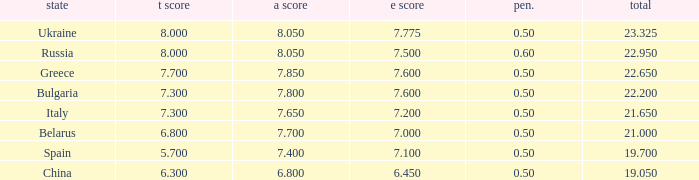What's the sum of A Score that also has a score lower than 7.3 and an E Score larger than 7.1? None. 